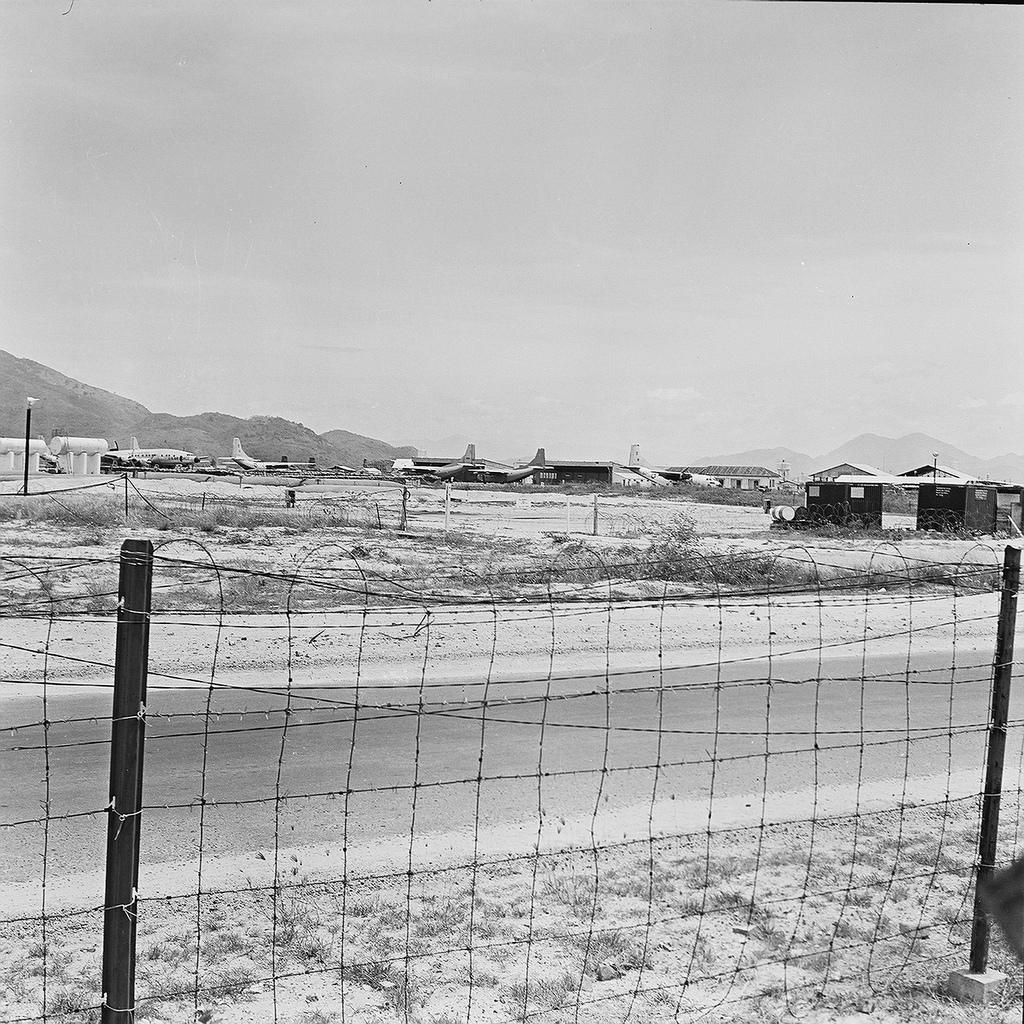What is the color scheme of the image? The image is in black and white. What type of structure can be seen in the image? There is a fence in the image. What can be found on the ground in the image? There is a path in the image. What is located along the path in the image? Airplanes are present on the path. What is visible in the background of the image? There is a hill and the sky visible in the background of the image. How many pigs are visible on the hill in the image? There are no pigs present in the image; only a hill and the sky are visible in the background. What type of footwear is the person wearing in the image? There is no person present in the image, so it is not possible to determine what type of footwear they might be wearing. 